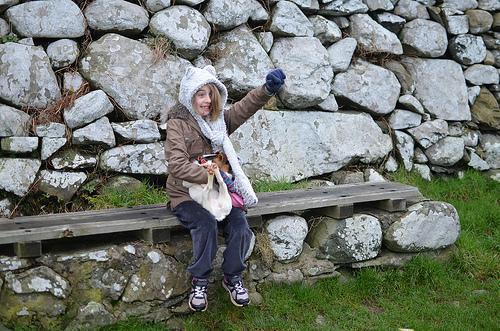How many girls are there?
Give a very brief answer. 1. 